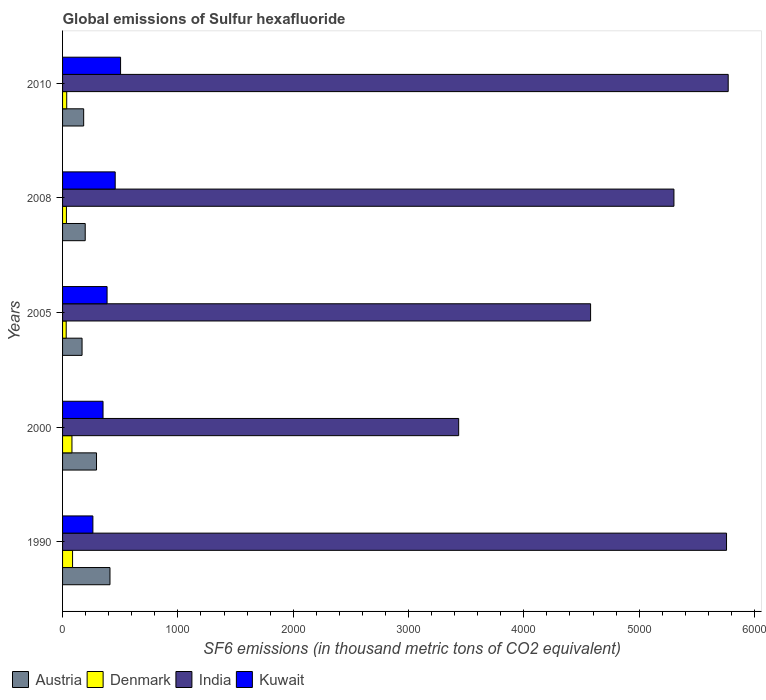How many different coloured bars are there?
Offer a very short reply. 4. How many bars are there on the 4th tick from the top?
Your answer should be very brief. 4. How many bars are there on the 1st tick from the bottom?
Your answer should be compact. 4. What is the label of the 2nd group of bars from the top?
Offer a terse response. 2008. In how many cases, is the number of bars for a given year not equal to the number of legend labels?
Your response must be concise. 0. What is the global emissions of Sulfur hexafluoride in Kuwait in 2008?
Keep it short and to the point. 456.4. Across all years, what is the maximum global emissions of Sulfur hexafluoride in India?
Your answer should be compact. 5772. Across all years, what is the minimum global emissions of Sulfur hexafluoride in Austria?
Give a very brief answer. 169. In which year was the global emissions of Sulfur hexafluoride in Kuwait maximum?
Your answer should be compact. 2010. In which year was the global emissions of Sulfur hexafluoride in Denmark minimum?
Your answer should be compact. 2005. What is the total global emissions of Sulfur hexafluoride in Denmark in the graph?
Make the answer very short. 269.1. What is the difference between the global emissions of Sulfur hexafluoride in India in 1990 and that in 2000?
Your answer should be very brief. 2322.8. What is the average global emissions of Sulfur hexafluoride in India per year?
Provide a succinct answer. 4968.86. In the year 1990, what is the difference between the global emissions of Sulfur hexafluoride in Kuwait and global emissions of Sulfur hexafluoride in India?
Provide a succinct answer. -5494.5. What is the ratio of the global emissions of Sulfur hexafluoride in Denmark in 1990 to that in 2008?
Your answer should be very brief. 2.59. What is the difference between the highest and the second highest global emissions of Sulfur hexafluoride in India?
Make the answer very short. 14.5. What is the difference between the highest and the lowest global emissions of Sulfur hexafluoride in Kuwait?
Make the answer very short. 240. Is the sum of the global emissions of Sulfur hexafluoride in Austria in 2008 and 2010 greater than the maximum global emissions of Sulfur hexafluoride in Kuwait across all years?
Your answer should be very brief. No. What does the 1st bar from the top in 2005 represents?
Keep it short and to the point. Kuwait. What does the 1st bar from the bottom in 2000 represents?
Your answer should be compact. Austria. Where does the legend appear in the graph?
Provide a succinct answer. Bottom left. How many legend labels are there?
Give a very brief answer. 4. What is the title of the graph?
Offer a terse response. Global emissions of Sulfur hexafluoride. Does "Least developed countries" appear as one of the legend labels in the graph?
Offer a very short reply. No. What is the label or title of the X-axis?
Make the answer very short. SF6 emissions (in thousand metric tons of CO2 equivalent). What is the SF6 emissions (in thousand metric tons of CO2 equivalent) in Austria in 1990?
Provide a succinct answer. 411.2. What is the SF6 emissions (in thousand metric tons of CO2 equivalent) of Denmark in 1990?
Your answer should be very brief. 86.7. What is the SF6 emissions (in thousand metric tons of CO2 equivalent) in India in 1990?
Your answer should be compact. 5757.5. What is the SF6 emissions (in thousand metric tons of CO2 equivalent) in Kuwait in 1990?
Your response must be concise. 263. What is the SF6 emissions (in thousand metric tons of CO2 equivalent) of Austria in 2000?
Keep it short and to the point. 294.4. What is the SF6 emissions (in thousand metric tons of CO2 equivalent) in Denmark in 2000?
Your response must be concise. 81.4. What is the SF6 emissions (in thousand metric tons of CO2 equivalent) in India in 2000?
Keep it short and to the point. 3434.7. What is the SF6 emissions (in thousand metric tons of CO2 equivalent) in Kuwait in 2000?
Provide a short and direct response. 350.9. What is the SF6 emissions (in thousand metric tons of CO2 equivalent) of Austria in 2005?
Offer a terse response. 169. What is the SF6 emissions (in thousand metric tons of CO2 equivalent) in Denmark in 2005?
Keep it short and to the point. 31.5. What is the SF6 emissions (in thousand metric tons of CO2 equivalent) in India in 2005?
Your answer should be compact. 4578.7. What is the SF6 emissions (in thousand metric tons of CO2 equivalent) in Kuwait in 2005?
Provide a short and direct response. 386. What is the SF6 emissions (in thousand metric tons of CO2 equivalent) in Austria in 2008?
Your answer should be very brief. 196.4. What is the SF6 emissions (in thousand metric tons of CO2 equivalent) of Denmark in 2008?
Give a very brief answer. 33.5. What is the SF6 emissions (in thousand metric tons of CO2 equivalent) of India in 2008?
Your answer should be compact. 5301.4. What is the SF6 emissions (in thousand metric tons of CO2 equivalent) of Kuwait in 2008?
Your answer should be very brief. 456.4. What is the SF6 emissions (in thousand metric tons of CO2 equivalent) of Austria in 2010?
Your answer should be compact. 183. What is the SF6 emissions (in thousand metric tons of CO2 equivalent) in India in 2010?
Provide a succinct answer. 5772. What is the SF6 emissions (in thousand metric tons of CO2 equivalent) in Kuwait in 2010?
Ensure brevity in your answer.  503. Across all years, what is the maximum SF6 emissions (in thousand metric tons of CO2 equivalent) in Austria?
Ensure brevity in your answer.  411.2. Across all years, what is the maximum SF6 emissions (in thousand metric tons of CO2 equivalent) of Denmark?
Offer a very short reply. 86.7. Across all years, what is the maximum SF6 emissions (in thousand metric tons of CO2 equivalent) in India?
Your answer should be very brief. 5772. Across all years, what is the maximum SF6 emissions (in thousand metric tons of CO2 equivalent) of Kuwait?
Make the answer very short. 503. Across all years, what is the minimum SF6 emissions (in thousand metric tons of CO2 equivalent) of Austria?
Your answer should be compact. 169. Across all years, what is the minimum SF6 emissions (in thousand metric tons of CO2 equivalent) of Denmark?
Offer a very short reply. 31.5. Across all years, what is the minimum SF6 emissions (in thousand metric tons of CO2 equivalent) of India?
Provide a succinct answer. 3434.7. Across all years, what is the minimum SF6 emissions (in thousand metric tons of CO2 equivalent) in Kuwait?
Offer a very short reply. 263. What is the total SF6 emissions (in thousand metric tons of CO2 equivalent) of Austria in the graph?
Offer a terse response. 1254. What is the total SF6 emissions (in thousand metric tons of CO2 equivalent) in Denmark in the graph?
Your answer should be very brief. 269.1. What is the total SF6 emissions (in thousand metric tons of CO2 equivalent) in India in the graph?
Ensure brevity in your answer.  2.48e+04. What is the total SF6 emissions (in thousand metric tons of CO2 equivalent) of Kuwait in the graph?
Offer a very short reply. 1959.3. What is the difference between the SF6 emissions (in thousand metric tons of CO2 equivalent) in Austria in 1990 and that in 2000?
Give a very brief answer. 116.8. What is the difference between the SF6 emissions (in thousand metric tons of CO2 equivalent) of India in 1990 and that in 2000?
Provide a succinct answer. 2322.8. What is the difference between the SF6 emissions (in thousand metric tons of CO2 equivalent) of Kuwait in 1990 and that in 2000?
Your answer should be compact. -87.9. What is the difference between the SF6 emissions (in thousand metric tons of CO2 equivalent) of Austria in 1990 and that in 2005?
Provide a succinct answer. 242.2. What is the difference between the SF6 emissions (in thousand metric tons of CO2 equivalent) in Denmark in 1990 and that in 2005?
Ensure brevity in your answer.  55.2. What is the difference between the SF6 emissions (in thousand metric tons of CO2 equivalent) of India in 1990 and that in 2005?
Your response must be concise. 1178.8. What is the difference between the SF6 emissions (in thousand metric tons of CO2 equivalent) in Kuwait in 1990 and that in 2005?
Offer a terse response. -123. What is the difference between the SF6 emissions (in thousand metric tons of CO2 equivalent) in Austria in 1990 and that in 2008?
Provide a short and direct response. 214.8. What is the difference between the SF6 emissions (in thousand metric tons of CO2 equivalent) of Denmark in 1990 and that in 2008?
Provide a succinct answer. 53.2. What is the difference between the SF6 emissions (in thousand metric tons of CO2 equivalent) in India in 1990 and that in 2008?
Ensure brevity in your answer.  456.1. What is the difference between the SF6 emissions (in thousand metric tons of CO2 equivalent) in Kuwait in 1990 and that in 2008?
Ensure brevity in your answer.  -193.4. What is the difference between the SF6 emissions (in thousand metric tons of CO2 equivalent) in Austria in 1990 and that in 2010?
Provide a short and direct response. 228.2. What is the difference between the SF6 emissions (in thousand metric tons of CO2 equivalent) of Denmark in 1990 and that in 2010?
Provide a short and direct response. 50.7. What is the difference between the SF6 emissions (in thousand metric tons of CO2 equivalent) of Kuwait in 1990 and that in 2010?
Your answer should be very brief. -240. What is the difference between the SF6 emissions (in thousand metric tons of CO2 equivalent) of Austria in 2000 and that in 2005?
Your response must be concise. 125.4. What is the difference between the SF6 emissions (in thousand metric tons of CO2 equivalent) of Denmark in 2000 and that in 2005?
Your answer should be very brief. 49.9. What is the difference between the SF6 emissions (in thousand metric tons of CO2 equivalent) in India in 2000 and that in 2005?
Make the answer very short. -1144. What is the difference between the SF6 emissions (in thousand metric tons of CO2 equivalent) in Kuwait in 2000 and that in 2005?
Make the answer very short. -35.1. What is the difference between the SF6 emissions (in thousand metric tons of CO2 equivalent) of Austria in 2000 and that in 2008?
Provide a succinct answer. 98. What is the difference between the SF6 emissions (in thousand metric tons of CO2 equivalent) of Denmark in 2000 and that in 2008?
Give a very brief answer. 47.9. What is the difference between the SF6 emissions (in thousand metric tons of CO2 equivalent) in India in 2000 and that in 2008?
Ensure brevity in your answer.  -1866.7. What is the difference between the SF6 emissions (in thousand metric tons of CO2 equivalent) in Kuwait in 2000 and that in 2008?
Provide a short and direct response. -105.5. What is the difference between the SF6 emissions (in thousand metric tons of CO2 equivalent) in Austria in 2000 and that in 2010?
Provide a succinct answer. 111.4. What is the difference between the SF6 emissions (in thousand metric tons of CO2 equivalent) in Denmark in 2000 and that in 2010?
Provide a succinct answer. 45.4. What is the difference between the SF6 emissions (in thousand metric tons of CO2 equivalent) in India in 2000 and that in 2010?
Your response must be concise. -2337.3. What is the difference between the SF6 emissions (in thousand metric tons of CO2 equivalent) of Kuwait in 2000 and that in 2010?
Keep it short and to the point. -152.1. What is the difference between the SF6 emissions (in thousand metric tons of CO2 equivalent) in Austria in 2005 and that in 2008?
Make the answer very short. -27.4. What is the difference between the SF6 emissions (in thousand metric tons of CO2 equivalent) of India in 2005 and that in 2008?
Keep it short and to the point. -722.7. What is the difference between the SF6 emissions (in thousand metric tons of CO2 equivalent) in Kuwait in 2005 and that in 2008?
Offer a very short reply. -70.4. What is the difference between the SF6 emissions (in thousand metric tons of CO2 equivalent) in Austria in 2005 and that in 2010?
Keep it short and to the point. -14. What is the difference between the SF6 emissions (in thousand metric tons of CO2 equivalent) in India in 2005 and that in 2010?
Give a very brief answer. -1193.3. What is the difference between the SF6 emissions (in thousand metric tons of CO2 equivalent) in Kuwait in 2005 and that in 2010?
Make the answer very short. -117. What is the difference between the SF6 emissions (in thousand metric tons of CO2 equivalent) in India in 2008 and that in 2010?
Keep it short and to the point. -470.6. What is the difference between the SF6 emissions (in thousand metric tons of CO2 equivalent) in Kuwait in 2008 and that in 2010?
Give a very brief answer. -46.6. What is the difference between the SF6 emissions (in thousand metric tons of CO2 equivalent) in Austria in 1990 and the SF6 emissions (in thousand metric tons of CO2 equivalent) in Denmark in 2000?
Your answer should be compact. 329.8. What is the difference between the SF6 emissions (in thousand metric tons of CO2 equivalent) of Austria in 1990 and the SF6 emissions (in thousand metric tons of CO2 equivalent) of India in 2000?
Give a very brief answer. -3023.5. What is the difference between the SF6 emissions (in thousand metric tons of CO2 equivalent) of Austria in 1990 and the SF6 emissions (in thousand metric tons of CO2 equivalent) of Kuwait in 2000?
Offer a very short reply. 60.3. What is the difference between the SF6 emissions (in thousand metric tons of CO2 equivalent) in Denmark in 1990 and the SF6 emissions (in thousand metric tons of CO2 equivalent) in India in 2000?
Ensure brevity in your answer.  -3348. What is the difference between the SF6 emissions (in thousand metric tons of CO2 equivalent) in Denmark in 1990 and the SF6 emissions (in thousand metric tons of CO2 equivalent) in Kuwait in 2000?
Provide a succinct answer. -264.2. What is the difference between the SF6 emissions (in thousand metric tons of CO2 equivalent) of India in 1990 and the SF6 emissions (in thousand metric tons of CO2 equivalent) of Kuwait in 2000?
Keep it short and to the point. 5406.6. What is the difference between the SF6 emissions (in thousand metric tons of CO2 equivalent) in Austria in 1990 and the SF6 emissions (in thousand metric tons of CO2 equivalent) in Denmark in 2005?
Your answer should be very brief. 379.7. What is the difference between the SF6 emissions (in thousand metric tons of CO2 equivalent) of Austria in 1990 and the SF6 emissions (in thousand metric tons of CO2 equivalent) of India in 2005?
Provide a succinct answer. -4167.5. What is the difference between the SF6 emissions (in thousand metric tons of CO2 equivalent) of Austria in 1990 and the SF6 emissions (in thousand metric tons of CO2 equivalent) of Kuwait in 2005?
Your answer should be compact. 25.2. What is the difference between the SF6 emissions (in thousand metric tons of CO2 equivalent) of Denmark in 1990 and the SF6 emissions (in thousand metric tons of CO2 equivalent) of India in 2005?
Offer a very short reply. -4492. What is the difference between the SF6 emissions (in thousand metric tons of CO2 equivalent) of Denmark in 1990 and the SF6 emissions (in thousand metric tons of CO2 equivalent) of Kuwait in 2005?
Offer a terse response. -299.3. What is the difference between the SF6 emissions (in thousand metric tons of CO2 equivalent) in India in 1990 and the SF6 emissions (in thousand metric tons of CO2 equivalent) in Kuwait in 2005?
Give a very brief answer. 5371.5. What is the difference between the SF6 emissions (in thousand metric tons of CO2 equivalent) of Austria in 1990 and the SF6 emissions (in thousand metric tons of CO2 equivalent) of Denmark in 2008?
Your answer should be very brief. 377.7. What is the difference between the SF6 emissions (in thousand metric tons of CO2 equivalent) of Austria in 1990 and the SF6 emissions (in thousand metric tons of CO2 equivalent) of India in 2008?
Your answer should be very brief. -4890.2. What is the difference between the SF6 emissions (in thousand metric tons of CO2 equivalent) of Austria in 1990 and the SF6 emissions (in thousand metric tons of CO2 equivalent) of Kuwait in 2008?
Make the answer very short. -45.2. What is the difference between the SF6 emissions (in thousand metric tons of CO2 equivalent) of Denmark in 1990 and the SF6 emissions (in thousand metric tons of CO2 equivalent) of India in 2008?
Make the answer very short. -5214.7. What is the difference between the SF6 emissions (in thousand metric tons of CO2 equivalent) in Denmark in 1990 and the SF6 emissions (in thousand metric tons of CO2 equivalent) in Kuwait in 2008?
Ensure brevity in your answer.  -369.7. What is the difference between the SF6 emissions (in thousand metric tons of CO2 equivalent) in India in 1990 and the SF6 emissions (in thousand metric tons of CO2 equivalent) in Kuwait in 2008?
Give a very brief answer. 5301.1. What is the difference between the SF6 emissions (in thousand metric tons of CO2 equivalent) of Austria in 1990 and the SF6 emissions (in thousand metric tons of CO2 equivalent) of Denmark in 2010?
Offer a terse response. 375.2. What is the difference between the SF6 emissions (in thousand metric tons of CO2 equivalent) of Austria in 1990 and the SF6 emissions (in thousand metric tons of CO2 equivalent) of India in 2010?
Your answer should be compact. -5360.8. What is the difference between the SF6 emissions (in thousand metric tons of CO2 equivalent) of Austria in 1990 and the SF6 emissions (in thousand metric tons of CO2 equivalent) of Kuwait in 2010?
Keep it short and to the point. -91.8. What is the difference between the SF6 emissions (in thousand metric tons of CO2 equivalent) of Denmark in 1990 and the SF6 emissions (in thousand metric tons of CO2 equivalent) of India in 2010?
Provide a succinct answer. -5685.3. What is the difference between the SF6 emissions (in thousand metric tons of CO2 equivalent) in Denmark in 1990 and the SF6 emissions (in thousand metric tons of CO2 equivalent) in Kuwait in 2010?
Make the answer very short. -416.3. What is the difference between the SF6 emissions (in thousand metric tons of CO2 equivalent) in India in 1990 and the SF6 emissions (in thousand metric tons of CO2 equivalent) in Kuwait in 2010?
Your answer should be compact. 5254.5. What is the difference between the SF6 emissions (in thousand metric tons of CO2 equivalent) in Austria in 2000 and the SF6 emissions (in thousand metric tons of CO2 equivalent) in Denmark in 2005?
Offer a terse response. 262.9. What is the difference between the SF6 emissions (in thousand metric tons of CO2 equivalent) in Austria in 2000 and the SF6 emissions (in thousand metric tons of CO2 equivalent) in India in 2005?
Offer a terse response. -4284.3. What is the difference between the SF6 emissions (in thousand metric tons of CO2 equivalent) in Austria in 2000 and the SF6 emissions (in thousand metric tons of CO2 equivalent) in Kuwait in 2005?
Ensure brevity in your answer.  -91.6. What is the difference between the SF6 emissions (in thousand metric tons of CO2 equivalent) in Denmark in 2000 and the SF6 emissions (in thousand metric tons of CO2 equivalent) in India in 2005?
Your answer should be very brief. -4497.3. What is the difference between the SF6 emissions (in thousand metric tons of CO2 equivalent) in Denmark in 2000 and the SF6 emissions (in thousand metric tons of CO2 equivalent) in Kuwait in 2005?
Your answer should be compact. -304.6. What is the difference between the SF6 emissions (in thousand metric tons of CO2 equivalent) of India in 2000 and the SF6 emissions (in thousand metric tons of CO2 equivalent) of Kuwait in 2005?
Make the answer very short. 3048.7. What is the difference between the SF6 emissions (in thousand metric tons of CO2 equivalent) in Austria in 2000 and the SF6 emissions (in thousand metric tons of CO2 equivalent) in Denmark in 2008?
Provide a succinct answer. 260.9. What is the difference between the SF6 emissions (in thousand metric tons of CO2 equivalent) in Austria in 2000 and the SF6 emissions (in thousand metric tons of CO2 equivalent) in India in 2008?
Ensure brevity in your answer.  -5007. What is the difference between the SF6 emissions (in thousand metric tons of CO2 equivalent) of Austria in 2000 and the SF6 emissions (in thousand metric tons of CO2 equivalent) of Kuwait in 2008?
Give a very brief answer. -162. What is the difference between the SF6 emissions (in thousand metric tons of CO2 equivalent) of Denmark in 2000 and the SF6 emissions (in thousand metric tons of CO2 equivalent) of India in 2008?
Offer a very short reply. -5220. What is the difference between the SF6 emissions (in thousand metric tons of CO2 equivalent) in Denmark in 2000 and the SF6 emissions (in thousand metric tons of CO2 equivalent) in Kuwait in 2008?
Offer a terse response. -375. What is the difference between the SF6 emissions (in thousand metric tons of CO2 equivalent) of India in 2000 and the SF6 emissions (in thousand metric tons of CO2 equivalent) of Kuwait in 2008?
Your answer should be very brief. 2978.3. What is the difference between the SF6 emissions (in thousand metric tons of CO2 equivalent) in Austria in 2000 and the SF6 emissions (in thousand metric tons of CO2 equivalent) in Denmark in 2010?
Offer a terse response. 258.4. What is the difference between the SF6 emissions (in thousand metric tons of CO2 equivalent) in Austria in 2000 and the SF6 emissions (in thousand metric tons of CO2 equivalent) in India in 2010?
Provide a short and direct response. -5477.6. What is the difference between the SF6 emissions (in thousand metric tons of CO2 equivalent) in Austria in 2000 and the SF6 emissions (in thousand metric tons of CO2 equivalent) in Kuwait in 2010?
Your answer should be compact. -208.6. What is the difference between the SF6 emissions (in thousand metric tons of CO2 equivalent) in Denmark in 2000 and the SF6 emissions (in thousand metric tons of CO2 equivalent) in India in 2010?
Your response must be concise. -5690.6. What is the difference between the SF6 emissions (in thousand metric tons of CO2 equivalent) in Denmark in 2000 and the SF6 emissions (in thousand metric tons of CO2 equivalent) in Kuwait in 2010?
Provide a succinct answer. -421.6. What is the difference between the SF6 emissions (in thousand metric tons of CO2 equivalent) of India in 2000 and the SF6 emissions (in thousand metric tons of CO2 equivalent) of Kuwait in 2010?
Provide a short and direct response. 2931.7. What is the difference between the SF6 emissions (in thousand metric tons of CO2 equivalent) in Austria in 2005 and the SF6 emissions (in thousand metric tons of CO2 equivalent) in Denmark in 2008?
Your answer should be compact. 135.5. What is the difference between the SF6 emissions (in thousand metric tons of CO2 equivalent) in Austria in 2005 and the SF6 emissions (in thousand metric tons of CO2 equivalent) in India in 2008?
Offer a terse response. -5132.4. What is the difference between the SF6 emissions (in thousand metric tons of CO2 equivalent) of Austria in 2005 and the SF6 emissions (in thousand metric tons of CO2 equivalent) of Kuwait in 2008?
Provide a succinct answer. -287.4. What is the difference between the SF6 emissions (in thousand metric tons of CO2 equivalent) in Denmark in 2005 and the SF6 emissions (in thousand metric tons of CO2 equivalent) in India in 2008?
Keep it short and to the point. -5269.9. What is the difference between the SF6 emissions (in thousand metric tons of CO2 equivalent) of Denmark in 2005 and the SF6 emissions (in thousand metric tons of CO2 equivalent) of Kuwait in 2008?
Offer a very short reply. -424.9. What is the difference between the SF6 emissions (in thousand metric tons of CO2 equivalent) of India in 2005 and the SF6 emissions (in thousand metric tons of CO2 equivalent) of Kuwait in 2008?
Your answer should be very brief. 4122.3. What is the difference between the SF6 emissions (in thousand metric tons of CO2 equivalent) in Austria in 2005 and the SF6 emissions (in thousand metric tons of CO2 equivalent) in Denmark in 2010?
Keep it short and to the point. 133. What is the difference between the SF6 emissions (in thousand metric tons of CO2 equivalent) of Austria in 2005 and the SF6 emissions (in thousand metric tons of CO2 equivalent) of India in 2010?
Give a very brief answer. -5603. What is the difference between the SF6 emissions (in thousand metric tons of CO2 equivalent) of Austria in 2005 and the SF6 emissions (in thousand metric tons of CO2 equivalent) of Kuwait in 2010?
Provide a succinct answer. -334. What is the difference between the SF6 emissions (in thousand metric tons of CO2 equivalent) in Denmark in 2005 and the SF6 emissions (in thousand metric tons of CO2 equivalent) in India in 2010?
Make the answer very short. -5740.5. What is the difference between the SF6 emissions (in thousand metric tons of CO2 equivalent) in Denmark in 2005 and the SF6 emissions (in thousand metric tons of CO2 equivalent) in Kuwait in 2010?
Provide a succinct answer. -471.5. What is the difference between the SF6 emissions (in thousand metric tons of CO2 equivalent) of India in 2005 and the SF6 emissions (in thousand metric tons of CO2 equivalent) of Kuwait in 2010?
Your response must be concise. 4075.7. What is the difference between the SF6 emissions (in thousand metric tons of CO2 equivalent) in Austria in 2008 and the SF6 emissions (in thousand metric tons of CO2 equivalent) in Denmark in 2010?
Offer a terse response. 160.4. What is the difference between the SF6 emissions (in thousand metric tons of CO2 equivalent) in Austria in 2008 and the SF6 emissions (in thousand metric tons of CO2 equivalent) in India in 2010?
Ensure brevity in your answer.  -5575.6. What is the difference between the SF6 emissions (in thousand metric tons of CO2 equivalent) of Austria in 2008 and the SF6 emissions (in thousand metric tons of CO2 equivalent) of Kuwait in 2010?
Provide a succinct answer. -306.6. What is the difference between the SF6 emissions (in thousand metric tons of CO2 equivalent) of Denmark in 2008 and the SF6 emissions (in thousand metric tons of CO2 equivalent) of India in 2010?
Ensure brevity in your answer.  -5738.5. What is the difference between the SF6 emissions (in thousand metric tons of CO2 equivalent) of Denmark in 2008 and the SF6 emissions (in thousand metric tons of CO2 equivalent) of Kuwait in 2010?
Offer a very short reply. -469.5. What is the difference between the SF6 emissions (in thousand metric tons of CO2 equivalent) in India in 2008 and the SF6 emissions (in thousand metric tons of CO2 equivalent) in Kuwait in 2010?
Your response must be concise. 4798.4. What is the average SF6 emissions (in thousand metric tons of CO2 equivalent) of Austria per year?
Provide a short and direct response. 250.8. What is the average SF6 emissions (in thousand metric tons of CO2 equivalent) of Denmark per year?
Ensure brevity in your answer.  53.82. What is the average SF6 emissions (in thousand metric tons of CO2 equivalent) of India per year?
Give a very brief answer. 4968.86. What is the average SF6 emissions (in thousand metric tons of CO2 equivalent) of Kuwait per year?
Offer a terse response. 391.86. In the year 1990, what is the difference between the SF6 emissions (in thousand metric tons of CO2 equivalent) of Austria and SF6 emissions (in thousand metric tons of CO2 equivalent) of Denmark?
Your answer should be very brief. 324.5. In the year 1990, what is the difference between the SF6 emissions (in thousand metric tons of CO2 equivalent) of Austria and SF6 emissions (in thousand metric tons of CO2 equivalent) of India?
Offer a terse response. -5346.3. In the year 1990, what is the difference between the SF6 emissions (in thousand metric tons of CO2 equivalent) in Austria and SF6 emissions (in thousand metric tons of CO2 equivalent) in Kuwait?
Ensure brevity in your answer.  148.2. In the year 1990, what is the difference between the SF6 emissions (in thousand metric tons of CO2 equivalent) in Denmark and SF6 emissions (in thousand metric tons of CO2 equivalent) in India?
Your answer should be very brief. -5670.8. In the year 1990, what is the difference between the SF6 emissions (in thousand metric tons of CO2 equivalent) of Denmark and SF6 emissions (in thousand metric tons of CO2 equivalent) of Kuwait?
Your response must be concise. -176.3. In the year 1990, what is the difference between the SF6 emissions (in thousand metric tons of CO2 equivalent) in India and SF6 emissions (in thousand metric tons of CO2 equivalent) in Kuwait?
Keep it short and to the point. 5494.5. In the year 2000, what is the difference between the SF6 emissions (in thousand metric tons of CO2 equivalent) in Austria and SF6 emissions (in thousand metric tons of CO2 equivalent) in Denmark?
Your response must be concise. 213. In the year 2000, what is the difference between the SF6 emissions (in thousand metric tons of CO2 equivalent) of Austria and SF6 emissions (in thousand metric tons of CO2 equivalent) of India?
Give a very brief answer. -3140.3. In the year 2000, what is the difference between the SF6 emissions (in thousand metric tons of CO2 equivalent) of Austria and SF6 emissions (in thousand metric tons of CO2 equivalent) of Kuwait?
Offer a terse response. -56.5. In the year 2000, what is the difference between the SF6 emissions (in thousand metric tons of CO2 equivalent) of Denmark and SF6 emissions (in thousand metric tons of CO2 equivalent) of India?
Provide a succinct answer. -3353.3. In the year 2000, what is the difference between the SF6 emissions (in thousand metric tons of CO2 equivalent) of Denmark and SF6 emissions (in thousand metric tons of CO2 equivalent) of Kuwait?
Your answer should be very brief. -269.5. In the year 2000, what is the difference between the SF6 emissions (in thousand metric tons of CO2 equivalent) of India and SF6 emissions (in thousand metric tons of CO2 equivalent) of Kuwait?
Provide a succinct answer. 3083.8. In the year 2005, what is the difference between the SF6 emissions (in thousand metric tons of CO2 equivalent) of Austria and SF6 emissions (in thousand metric tons of CO2 equivalent) of Denmark?
Provide a short and direct response. 137.5. In the year 2005, what is the difference between the SF6 emissions (in thousand metric tons of CO2 equivalent) in Austria and SF6 emissions (in thousand metric tons of CO2 equivalent) in India?
Keep it short and to the point. -4409.7. In the year 2005, what is the difference between the SF6 emissions (in thousand metric tons of CO2 equivalent) in Austria and SF6 emissions (in thousand metric tons of CO2 equivalent) in Kuwait?
Your answer should be compact. -217. In the year 2005, what is the difference between the SF6 emissions (in thousand metric tons of CO2 equivalent) of Denmark and SF6 emissions (in thousand metric tons of CO2 equivalent) of India?
Ensure brevity in your answer.  -4547.2. In the year 2005, what is the difference between the SF6 emissions (in thousand metric tons of CO2 equivalent) in Denmark and SF6 emissions (in thousand metric tons of CO2 equivalent) in Kuwait?
Provide a short and direct response. -354.5. In the year 2005, what is the difference between the SF6 emissions (in thousand metric tons of CO2 equivalent) in India and SF6 emissions (in thousand metric tons of CO2 equivalent) in Kuwait?
Provide a short and direct response. 4192.7. In the year 2008, what is the difference between the SF6 emissions (in thousand metric tons of CO2 equivalent) in Austria and SF6 emissions (in thousand metric tons of CO2 equivalent) in Denmark?
Ensure brevity in your answer.  162.9. In the year 2008, what is the difference between the SF6 emissions (in thousand metric tons of CO2 equivalent) in Austria and SF6 emissions (in thousand metric tons of CO2 equivalent) in India?
Your answer should be compact. -5105. In the year 2008, what is the difference between the SF6 emissions (in thousand metric tons of CO2 equivalent) in Austria and SF6 emissions (in thousand metric tons of CO2 equivalent) in Kuwait?
Give a very brief answer. -260. In the year 2008, what is the difference between the SF6 emissions (in thousand metric tons of CO2 equivalent) in Denmark and SF6 emissions (in thousand metric tons of CO2 equivalent) in India?
Make the answer very short. -5267.9. In the year 2008, what is the difference between the SF6 emissions (in thousand metric tons of CO2 equivalent) of Denmark and SF6 emissions (in thousand metric tons of CO2 equivalent) of Kuwait?
Ensure brevity in your answer.  -422.9. In the year 2008, what is the difference between the SF6 emissions (in thousand metric tons of CO2 equivalent) of India and SF6 emissions (in thousand metric tons of CO2 equivalent) of Kuwait?
Provide a short and direct response. 4845. In the year 2010, what is the difference between the SF6 emissions (in thousand metric tons of CO2 equivalent) in Austria and SF6 emissions (in thousand metric tons of CO2 equivalent) in Denmark?
Offer a very short reply. 147. In the year 2010, what is the difference between the SF6 emissions (in thousand metric tons of CO2 equivalent) in Austria and SF6 emissions (in thousand metric tons of CO2 equivalent) in India?
Your answer should be very brief. -5589. In the year 2010, what is the difference between the SF6 emissions (in thousand metric tons of CO2 equivalent) of Austria and SF6 emissions (in thousand metric tons of CO2 equivalent) of Kuwait?
Give a very brief answer. -320. In the year 2010, what is the difference between the SF6 emissions (in thousand metric tons of CO2 equivalent) in Denmark and SF6 emissions (in thousand metric tons of CO2 equivalent) in India?
Give a very brief answer. -5736. In the year 2010, what is the difference between the SF6 emissions (in thousand metric tons of CO2 equivalent) of Denmark and SF6 emissions (in thousand metric tons of CO2 equivalent) of Kuwait?
Provide a short and direct response. -467. In the year 2010, what is the difference between the SF6 emissions (in thousand metric tons of CO2 equivalent) of India and SF6 emissions (in thousand metric tons of CO2 equivalent) of Kuwait?
Your answer should be very brief. 5269. What is the ratio of the SF6 emissions (in thousand metric tons of CO2 equivalent) in Austria in 1990 to that in 2000?
Make the answer very short. 1.4. What is the ratio of the SF6 emissions (in thousand metric tons of CO2 equivalent) of Denmark in 1990 to that in 2000?
Offer a terse response. 1.07. What is the ratio of the SF6 emissions (in thousand metric tons of CO2 equivalent) in India in 1990 to that in 2000?
Ensure brevity in your answer.  1.68. What is the ratio of the SF6 emissions (in thousand metric tons of CO2 equivalent) of Kuwait in 1990 to that in 2000?
Ensure brevity in your answer.  0.75. What is the ratio of the SF6 emissions (in thousand metric tons of CO2 equivalent) of Austria in 1990 to that in 2005?
Make the answer very short. 2.43. What is the ratio of the SF6 emissions (in thousand metric tons of CO2 equivalent) in Denmark in 1990 to that in 2005?
Your answer should be very brief. 2.75. What is the ratio of the SF6 emissions (in thousand metric tons of CO2 equivalent) in India in 1990 to that in 2005?
Your answer should be compact. 1.26. What is the ratio of the SF6 emissions (in thousand metric tons of CO2 equivalent) of Kuwait in 1990 to that in 2005?
Give a very brief answer. 0.68. What is the ratio of the SF6 emissions (in thousand metric tons of CO2 equivalent) of Austria in 1990 to that in 2008?
Your answer should be compact. 2.09. What is the ratio of the SF6 emissions (in thousand metric tons of CO2 equivalent) in Denmark in 1990 to that in 2008?
Provide a succinct answer. 2.59. What is the ratio of the SF6 emissions (in thousand metric tons of CO2 equivalent) in India in 1990 to that in 2008?
Keep it short and to the point. 1.09. What is the ratio of the SF6 emissions (in thousand metric tons of CO2 equivalent) of Kuwait in 1990 to that in 2008?
Offer a terse response. 0.58. What is the ratio of the SF6 emissions (in thousand metric tons of CO2 equivalent) of Austria in 1990 to that in 2010?
Ensure brevity in your answer.  2.25. What is the ratio of the SF6 emissions (in thousand metric tons of CO2 equivalent) in Denmark in 1990 to that in 2010?
Your response must be concise. 2.41. What is the ratio of the SF6 emissions (in thousand metric tons of CO2 equivalent) of India in 1990 to that in 2010?
Provide a short and direct response. 1. What is the ratio of the SF6 emissions (in thousand metric tons of CO2 equivalent) of Kuwait in 1990 to that in 2010?
Your answer should be very brief. 0.52. What is the ratio of the SF6 emissions (in thousand metric tons of CO2 equivalent) in Austria in 2000 to that in 2005?
Your response must be concise. 1.74. What is the ratio of the SF6 emissions (in thousand metric tons of CO2 equivalent) in Denmark in 2000 to that in 2005?
Offer a terse response. 2.58. What is the ratio of the SF6 emissions (in thousand metric tons of CO2 equivalent) in India in 2000 to that in 2005?
Your answer should be very brief. 0.75. What is the ratio of the SF6 emissions (in thousand metric tons of CO2 equivalent) of Kuwait in 2000 to that in 2005?
Make the answer very short. 0.91. What is the ratio of the SF6 emissions (in thousand metric tons of CO2 equivalent) of Austria in 2000 to that in 2008?
Your answer should be compact. 1.5. What is the ratio of the SF6 emissions (in thousand metric tons of CO2 equivalent) of Denmark in 2000 to that in 2008?
Keep it short and to the point. 2.43. What is the ratio of the SF6 emissions (in thousand metric tons of CO2 equivalent) of India in 2000 to that in 2008?
Make the answer very short. 0.65. What is the ratio of the SF6 emissions (in thousand metric tons of CO2 equivalent) in Kuwait in 2000 to that in 2008?
Offer a terse response. 0.77. What is the ratio of the SF6 emissions (in thousand metric tons of CO2 equivalent) of Austria in 2000 to that in 2010?
Offer a very short reply. 1.61. What is the ratio of the SF6 emissions (in thousand metric tons of CO2 equivalent) in Denmark in 2000 to that in 2010?
Your answer should be compact. 2.26. What is the ratio of the SF6 emissions (in thousand metric tons of CO2 equivalent) in India in 2000 to that in 2010?
Provide a short and direct response. 0.6. What is the ratio of the SF6 emissions (in thousand metric tons of CO2 equivalent) in Kuwait in 2000 to that in 2010?
Give a very brief answer. 0.7. What is the ratio of the SF6 emissions (in thousand metric tons of CO2 equivalent) in Austria in 2005 to that in 2008?
Ensure brevity in your answer.  0.86. What is the ratio of the SF6 emissions (in thousand metric tons of CO2 equivalent) of Denmark in 2005 to that in 2008?
Keep it short and to the point. 0.94. What is the ratio of the SF6 emissions (in thousand metric tons of CO2 equivalent) of India in 2005 to that in 2008?
Offer a terse response. 0.86. What is the ratio of the SF6 emissions (in thousand metric tons of CO2 equivalent) of Kuwait in 2005 to that in 2008?
Your response must be concise. 0.85. What is the ratio of the SF6 emissions (in thousand metric tons of CO2 equivalent) in Austria in 2005 to that in 2010?
Offer a terse response. 0.92. What is the ratio of the SF6 emissions (in thousand metric tons of CO2 equivalent) of Denmark in 2005 to that in 2010?
Your response must be concise. 0.88. What is the ratio of the SF6 emissions (in thousand metric tons of CO2 equivalent) in India in 2005 to that in 2010?
Make the answer very short. 0.79. What is the ratio of the SF6 emissions (in thousand metric tons of CO2 equivalent) of Kuwait in 2005 to that in 2010?
Your answer should be compact. 0.77. What is the ratio of the SF6 emissions (in thousand metric tons of CO2 equivalent) in Austria in 2008 to that in 2010?
Make the answer very short. 1.07. What is the ratio of the SF6 emissions (in thousand metric tons of CO2 equivalent) in Denmark in 2008 to that in 2010?
Ensure brevity in your answer.  0.93. What is the ratio of the SF6 emissions (in thousand metric tons of CO2 equivalent) in India in 2008 to that in 2010?
Provide a succinct answer. 0.92. What is the ratio of the SF6 emissions (in thousand metric tons of CO2 equivalent) of Kuwait in 2008 to that in 2010?
Ensure brevity in your answer.  0.91. What is the difference between the highest and the second highest SF6 emissions (in thousand metric tons of CO2 equivalent) of Austria?
Keep it short and to the point. 116.8. What is the difference between the highest and the second highest SF6 emissions (in thousand metric tons of CO2 equivalent) in Kuwait?
Make the answer very short. 46.6. What is the difference between the highest and the lowest SF6 emissions (in thousand metric tons of CO2 equivalent) of Austria?
Give a very brief answer. 242.2. What is the difference between the highest and the lowest SF6 emissions (in thousand metric tons of CO2 equivalent) of Denmark?
Your response must be concise. 55.2. What is the difference between the highest and the lowest SF6 emissions (in thousand metric tons of CO2 equivalent) of India?
Keep it short and to the point. 2337.3. What is the difference between the highest and the lowest SF6 emissions (in thousand metric tons of CO2 equivalent) in Kuwait?
Ensure brevity in your answer.  240. 